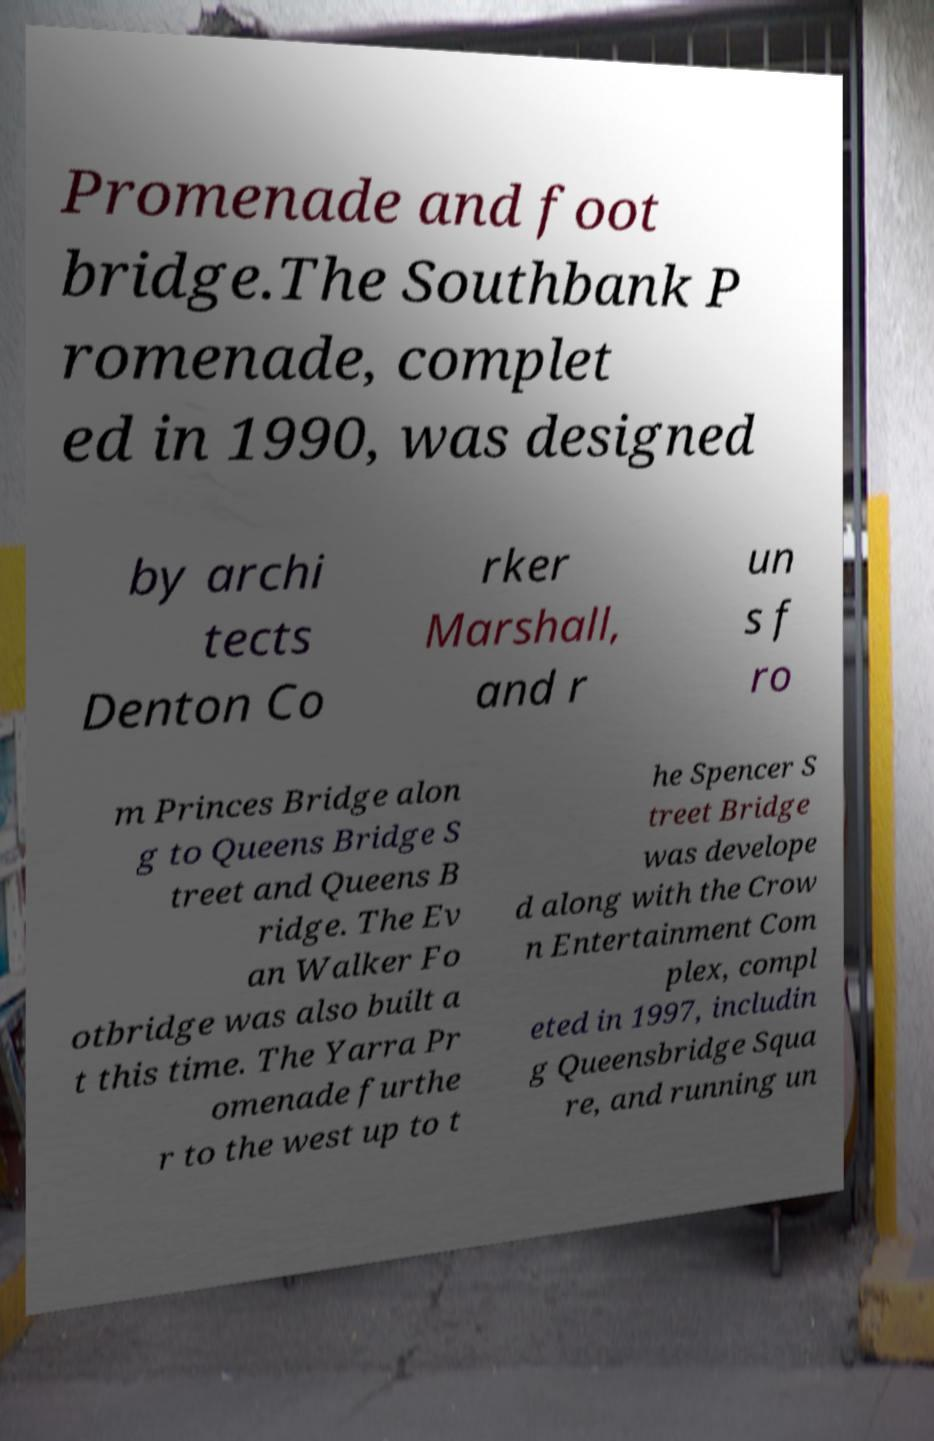For documentation purposes, I need the text within this image transcribed. Could you provide that? Promenade and foot bridge.The Southbank P romenade, complet ed in 1990, was designed by archi tects Denton Co rker Marshall, and r un s f ro m Princes Bridge alon g to Queens Bridge S treet and Queens B ridge. The Ev an Walker Fo otbridge was also built a t this time. The Yarra Pr omenade furthe r to the west up to t he Spencer S treet Bridge was develope d along with the Crow n Entertainment Com plex, compl eted in 1997, includin g Queensbridge Squa re, and running un 